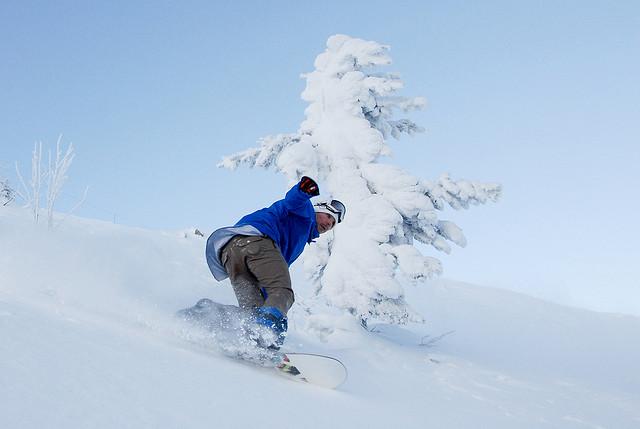Is this person touching the ground?
Short answer required. Yes. Is the snowboard parallel to the mountain?
Quick response, please. Yes. Why does the skier have his knees bent?
Be succinct. Turning. Is the man skinny?
Concise answer only. Yes. Is the snowboarder on the ground?
Quick response, please. Yes. What color is the snowboard?
Quick response, please. White. Is the man getting ready to fall into the snow?
Concise answer only. Yes. What is in the picture?
Be succinct. Snowboarder. Is the skier dress correctly for the weather?
Quick response, please. Yes. Is this a high jump?
Answer briefly. No. Is the person resting?
Quick response, please. No. Does the snow-covered tree resemble a rearing animal?
Short answer required. Yes. Is the skier wearing sun goggles?
Be succinct. Yes. What does the man have on his feet?
Concise answer only. Snowboard. 